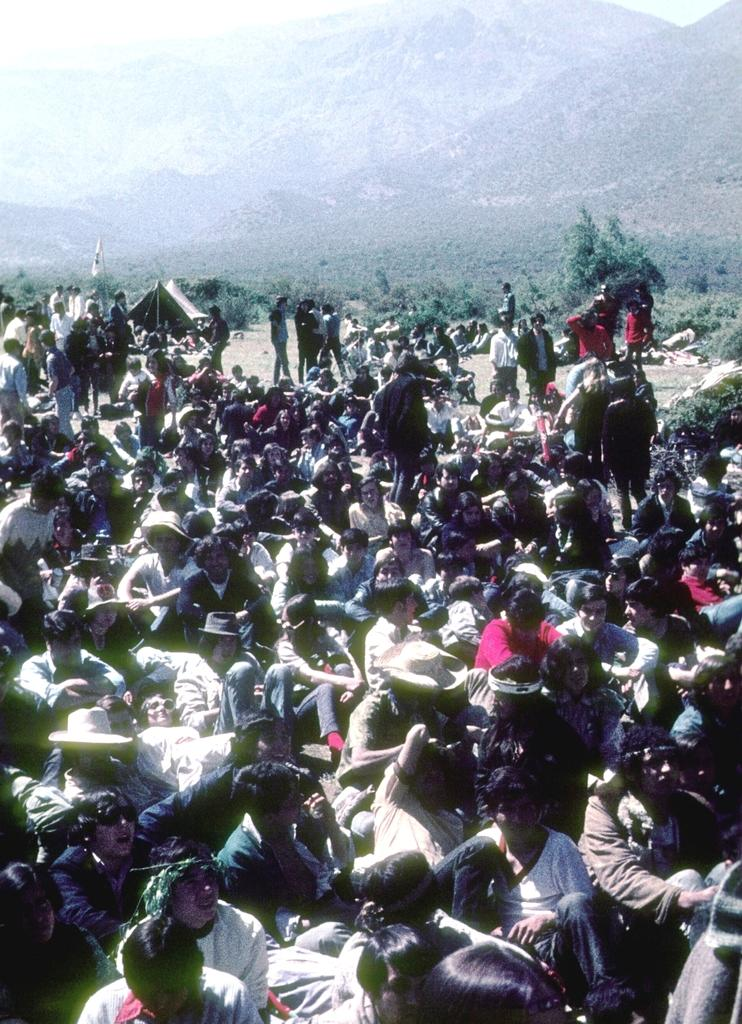How many people are in the image? There is a group of people in the image, but the exact number cannot be determined from the provided facts. What are the people in the image doing? Some of the people are sitting, while others are standing. What structure can be seen in the image? There is a tent in the image. What type of natural feature is visible in the image? There are hills visible in the image. What is visible at the top of the image? The sky is visible at the top of the image. Can you see any quicksand in the image? There is no quicksand present in the image. What type of lamp is illuminating the cemetery in the image? There is no cemetery or lamp present in the image. 